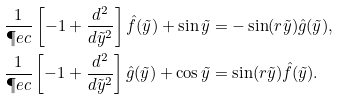<formula> <loc_0><loc_0><loc_500><loc_500>\frac { 1 } { \P e c } \left [ - 1 + \frac { d ^ { 2 } } { d \tilde { y } ^ { 2 } } \right ] \hat { f } ( \tilde { y } ) + \sin \tilde { y } & = - \sin ( r \tilde { y } ) \hat { g } ( \tilde { y } ) , \\ \frac { 1 } { \P e c } \left [ - 1 + \frac { d ^ { 2 } } { d \tilde { y } ^ { 2 } } \right ] \hat { g } ( \tilde { y } ) + \cos \tilde { y } & = \sin ( r \tilde { y } ) \hat { f } ( \tilde { y } ) .</formula> 